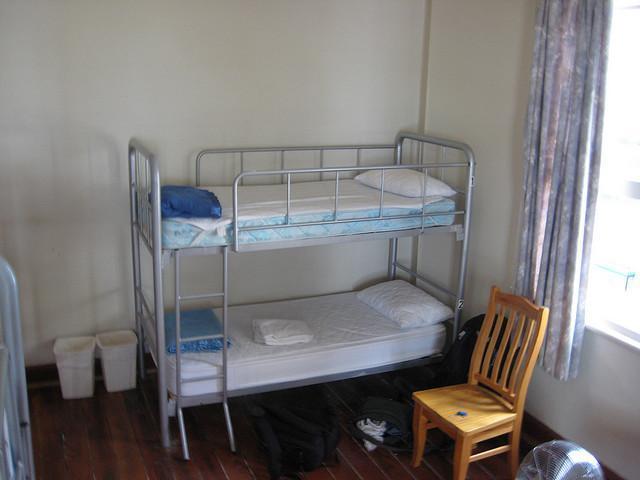How many towels are on the bed?
Give a very brief answer. 1. 